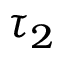<formula> <loc_0><loc_0><loc_500><loc_500>\tau _ { 2 }</formula> 